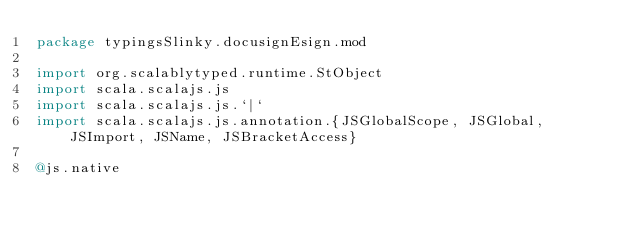<code> <loc_0><loc_0><loc_500><loc_500><_Scala_>package typingsSlinky.docusignEsign.mod

import org.scalablytyped.runtime.StObject
import scala.scalajs.js
import scala.scalajs.js.`|`
import scala.scalajs.js.annotation.{JSGlobalScope, JSGlobal, JSImport, JSName, JSBracketAccess}

@js.native</code> 